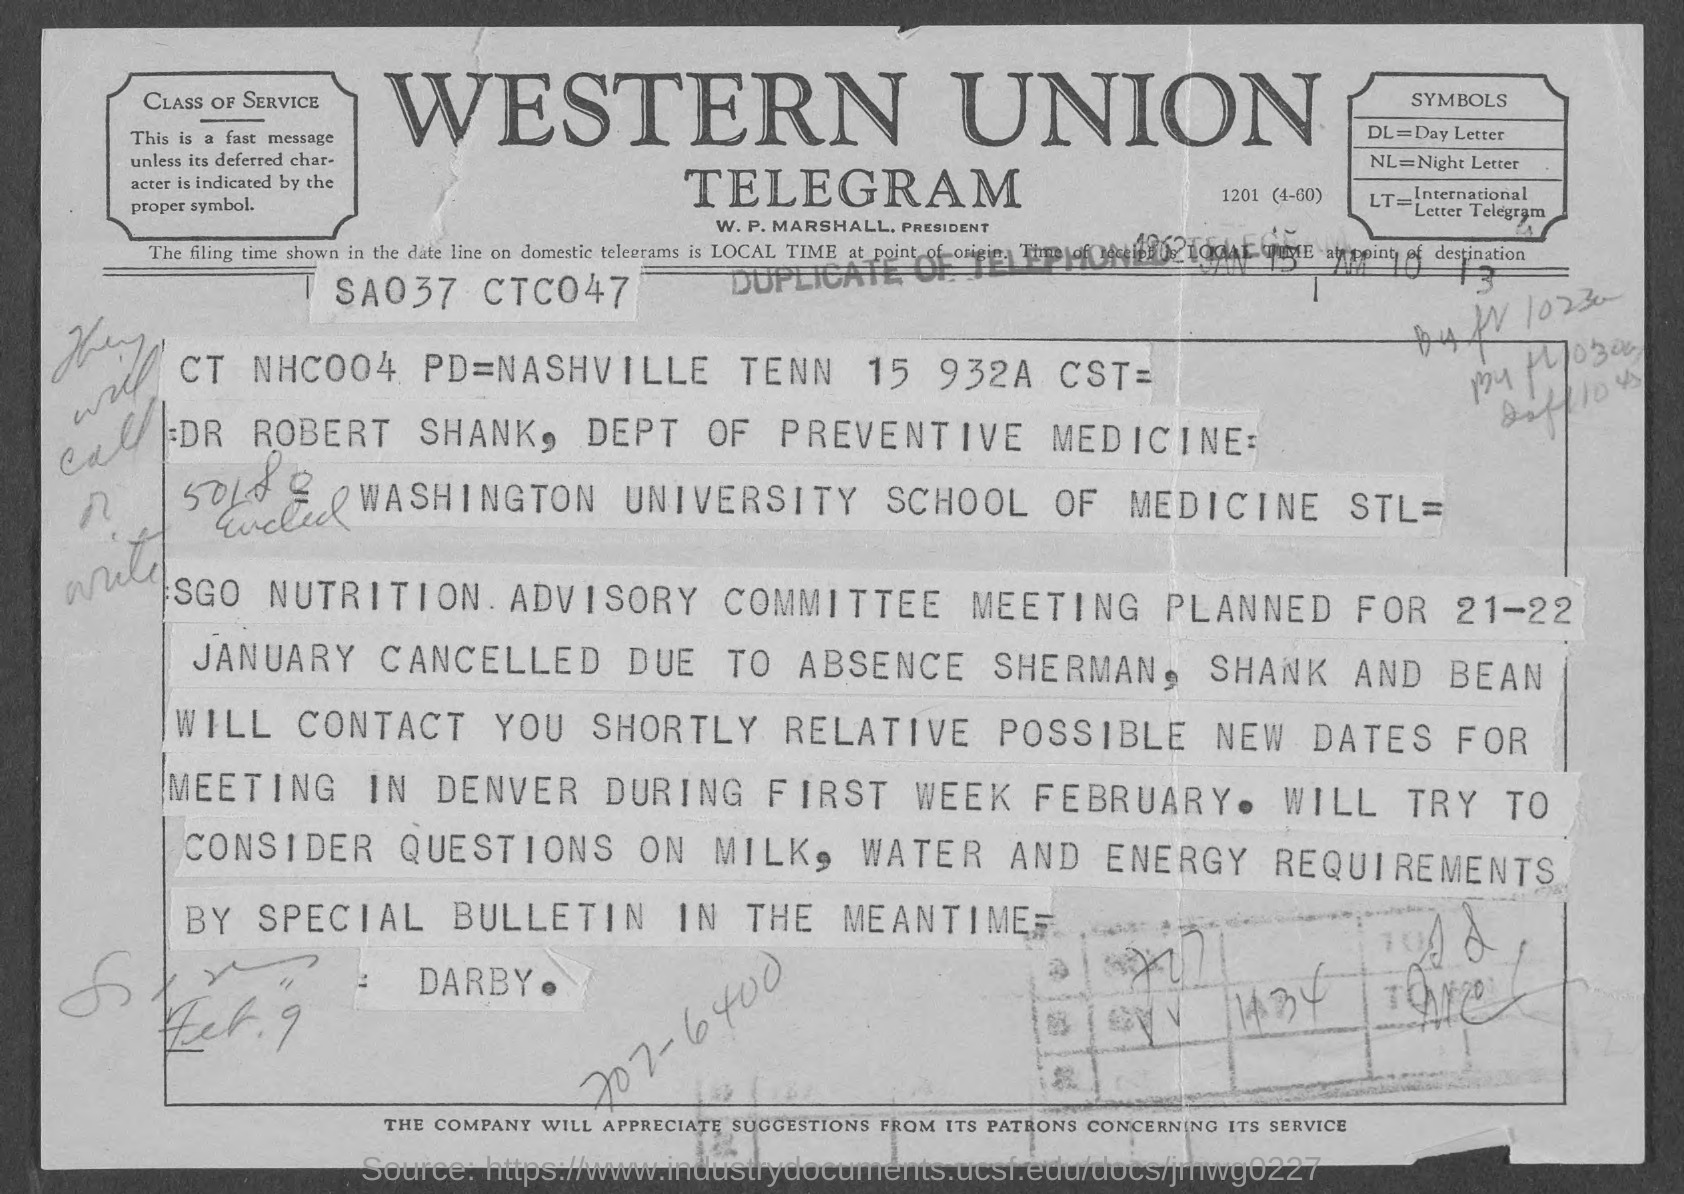Specify some key components in this picture. The symbol for day letter is DL. The symbol for an International Letter Telegram is LT. The President of Western Union Telegram is W. P. Marshall. The symbol for the night letter is NL. 